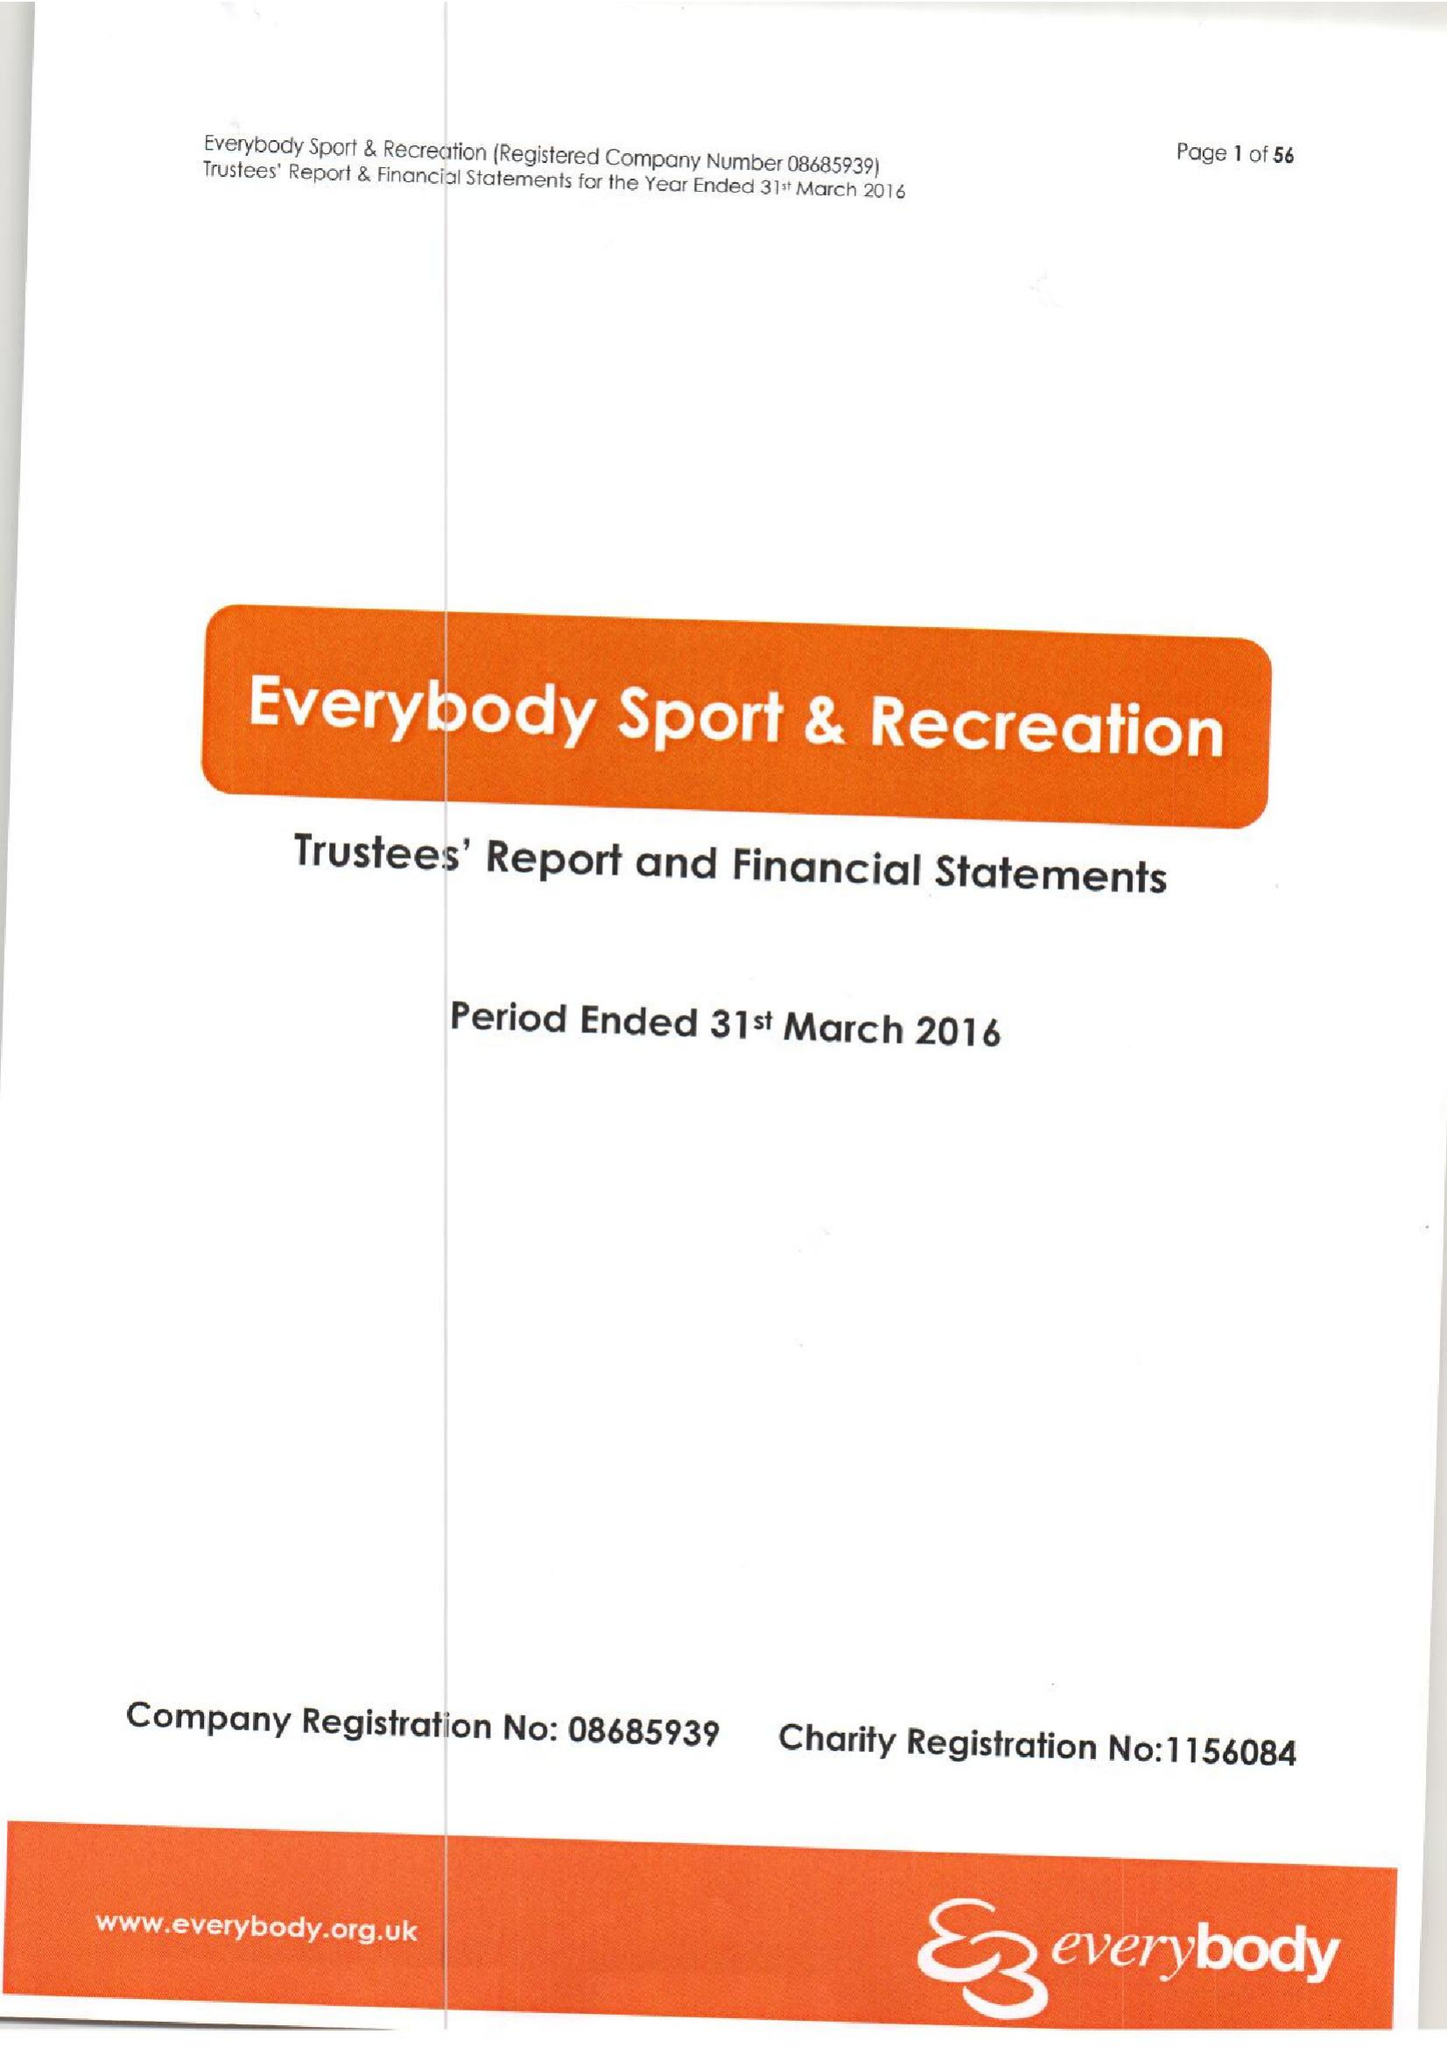What is the value for the address__postcode?
Answer the question using a single word or phrase. CW4 8AA 